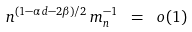<formula> <loc_0><loc_0><loc_500><loc_500>n ^ { ( 1 - \alpha d - 2 \beta ) / 2 } \, m _ { n } ^ { - 1 } \ = \ o ( 1 )</formula> 